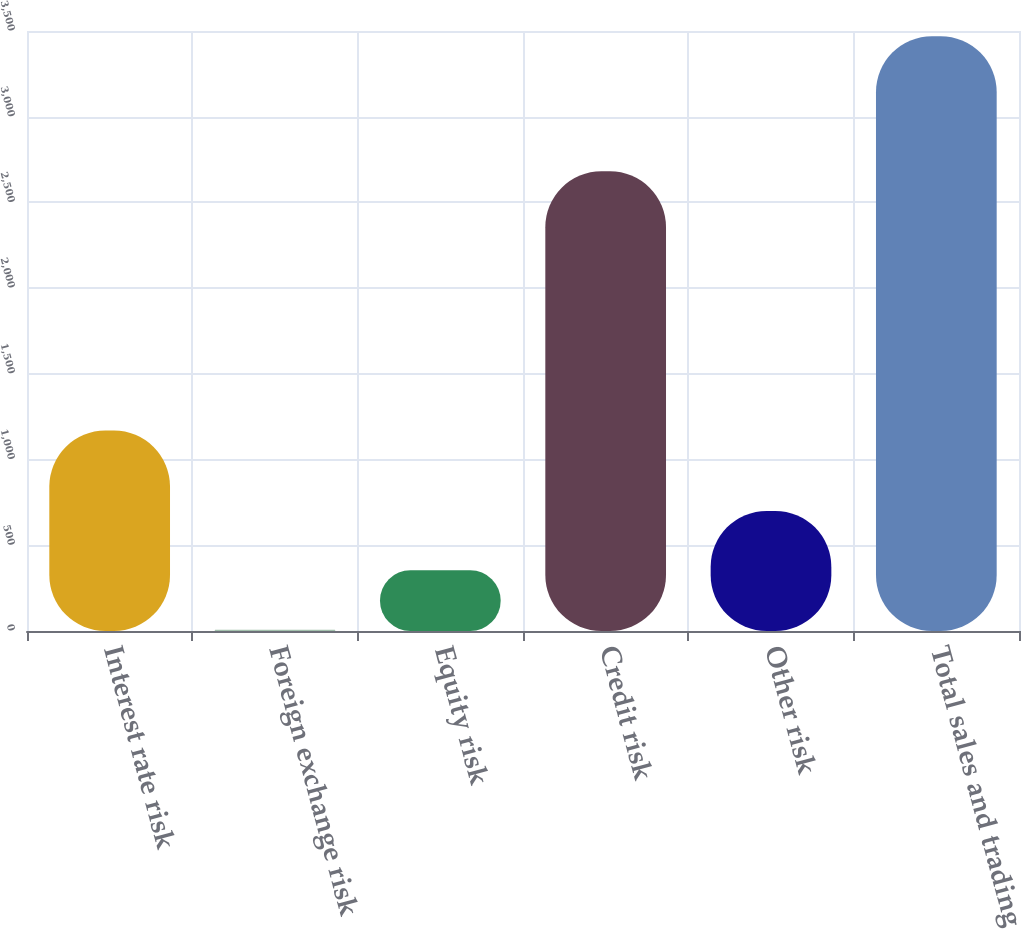Convert chart to OTSL. <chart><loc_0><loc_0><loc_500><loc_500><bar_chart><fcel>Interest rate risk<fcel>Foreign exchange risk<fcel>Equity risk<fcel>Credit risk<fcel>Other risk<fcel>Total sales and trading<nl><fcel>1169<fcel>8<fcel>354.2<fcel>2682<fcel>700.4<fcel>3470<nl></chart> 